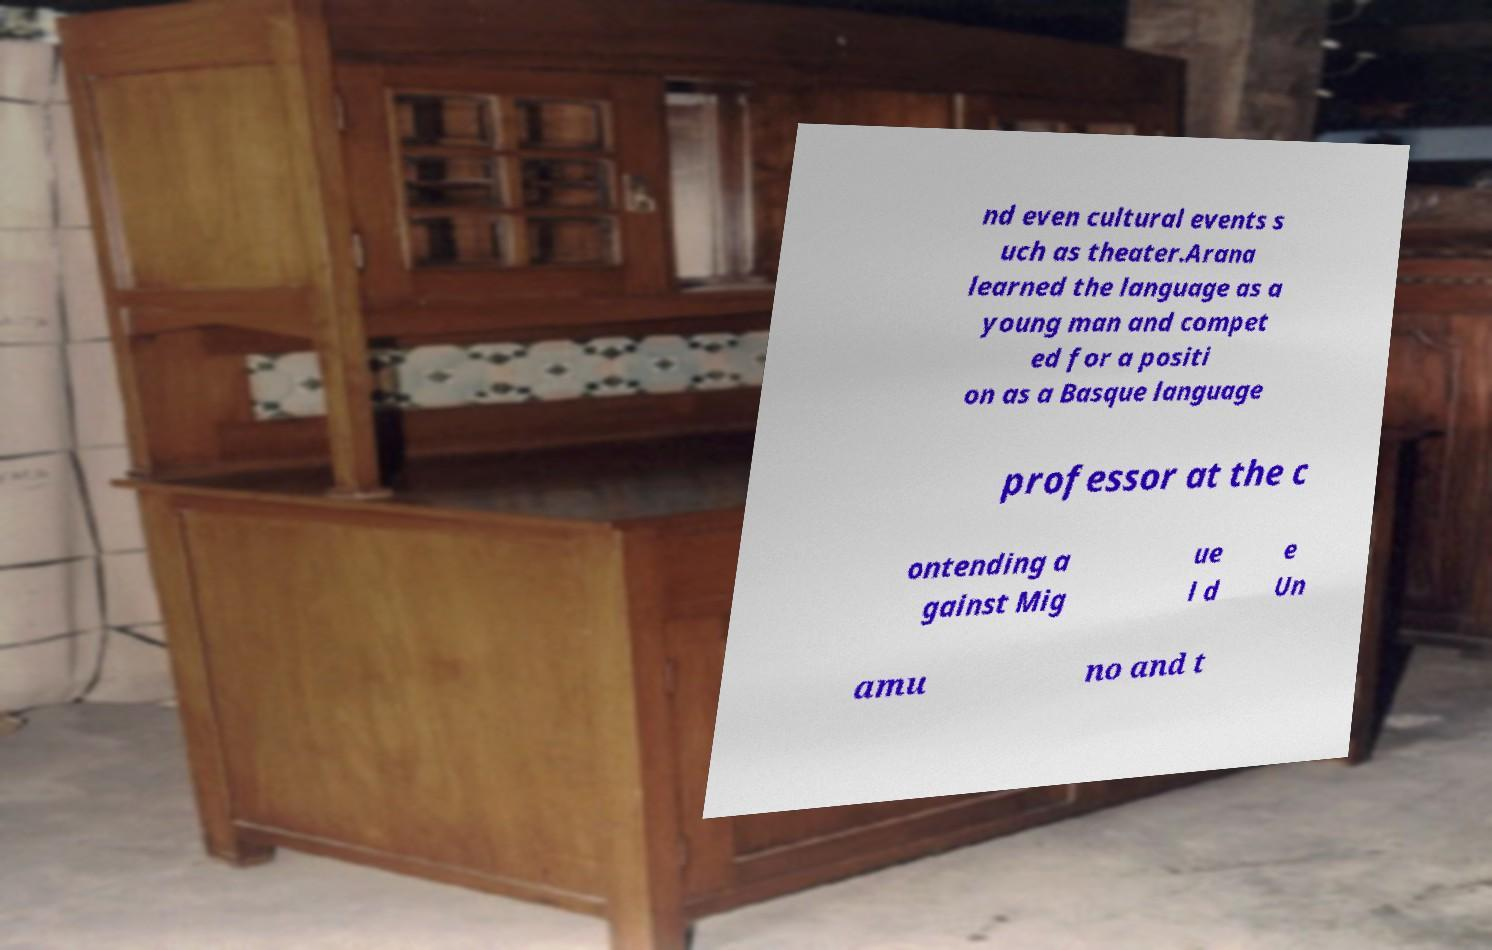Please identify and transcribe the text found in this image. nd even cultural events s uch as theater.Arana learned the language as a young man and compet ed for a positi on as a Basque language professor at the c ontending a gainst Mig ue l d e Un amu no and t 